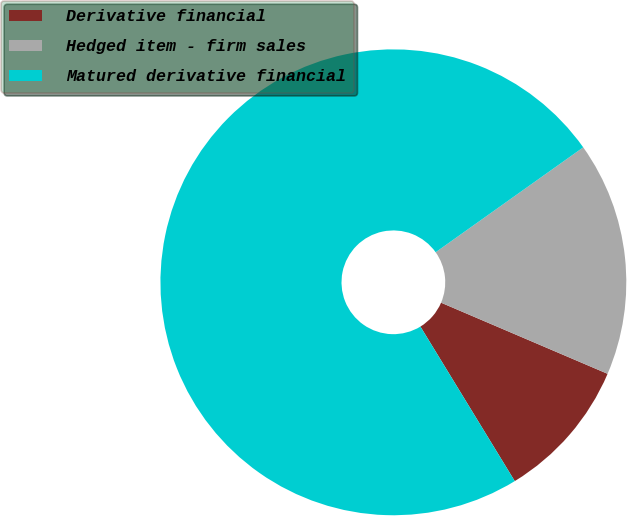<chart> <loc_0><loc_0><loc_500><loc_500><pie_chart><fcel>Derivative financial<fcel>Hedged item - firm sales<fcel>Matured derivative financial<nl><fcel>9.85%<fcel>16.26%<fcel>73.89%<nl></chart> 